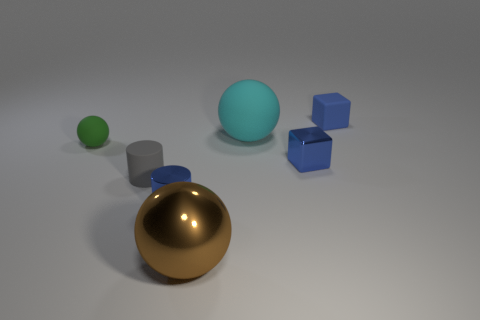Is there anything else that has the same material as the tiny green thing?
Your answer should be very brief. Yes. What is the color of the ball that is in front of the tiny shiny thing on the right side of the large thing that is behind the metal sphere?
Give a very brief answer. Brown. Are there fewer large gray matte cylinders than tiny rubber cylinders?
Your response must be concise. Yes. There is another big object that is the same shape as the large brown thing; what color is it?
Offer a very short reply. Cyan. What color is the large ball that is made of the same material as the small green ball?
Make the answer very short. Cyan. What number of green cylinders are the same size as the metal block?
Make the answer very short. 0. What is the cyan ball made of?
Ensure brevity in your answer.  Rubber. Are there more blue cylinders than yellow shiny cubes?
Make the answer very short. Yes. Is the shape of the gray thing the same as the small green rubber thing?
Your answer should be very brief. No. Is there anything else that has the same shape as the tiny green object?
Your answer should be compact. Yes. 